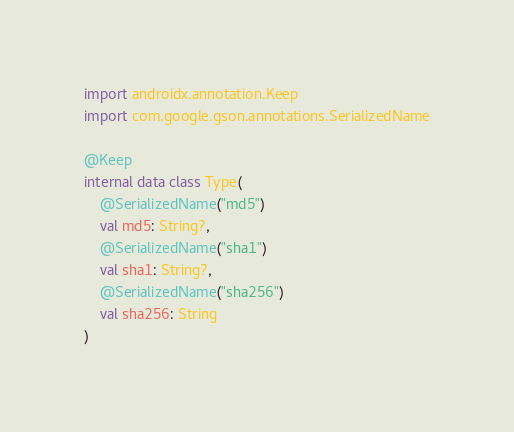<code> <loc_0><loc_0><loc_500><loc_500><_Kotlin_>import androidx.annotation.Keep
import com.google.gson.annotations.SerializedName

@Keep
internal data class Type(
    @SerializedName("md5")
    val md5: String?,
    @SerializedName("sha1")
    val sha1: String?,
    @SerializedName("sha256")
    val sha256: String
)</code> 